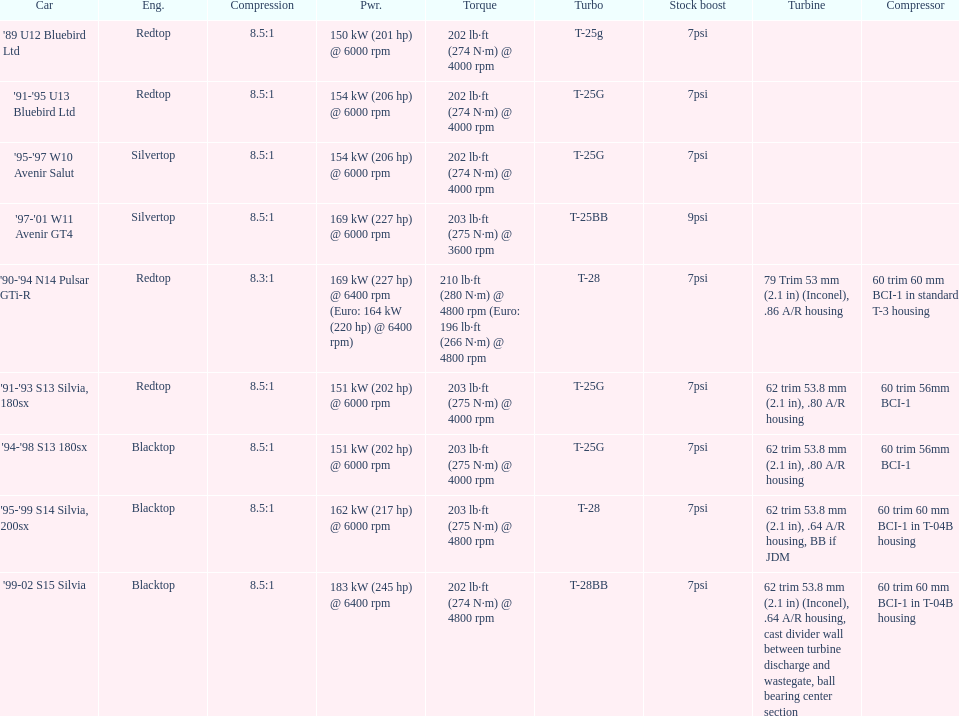Which car has a stock boost of over 7psi? '97-'01 W11 Avenir GT4. 